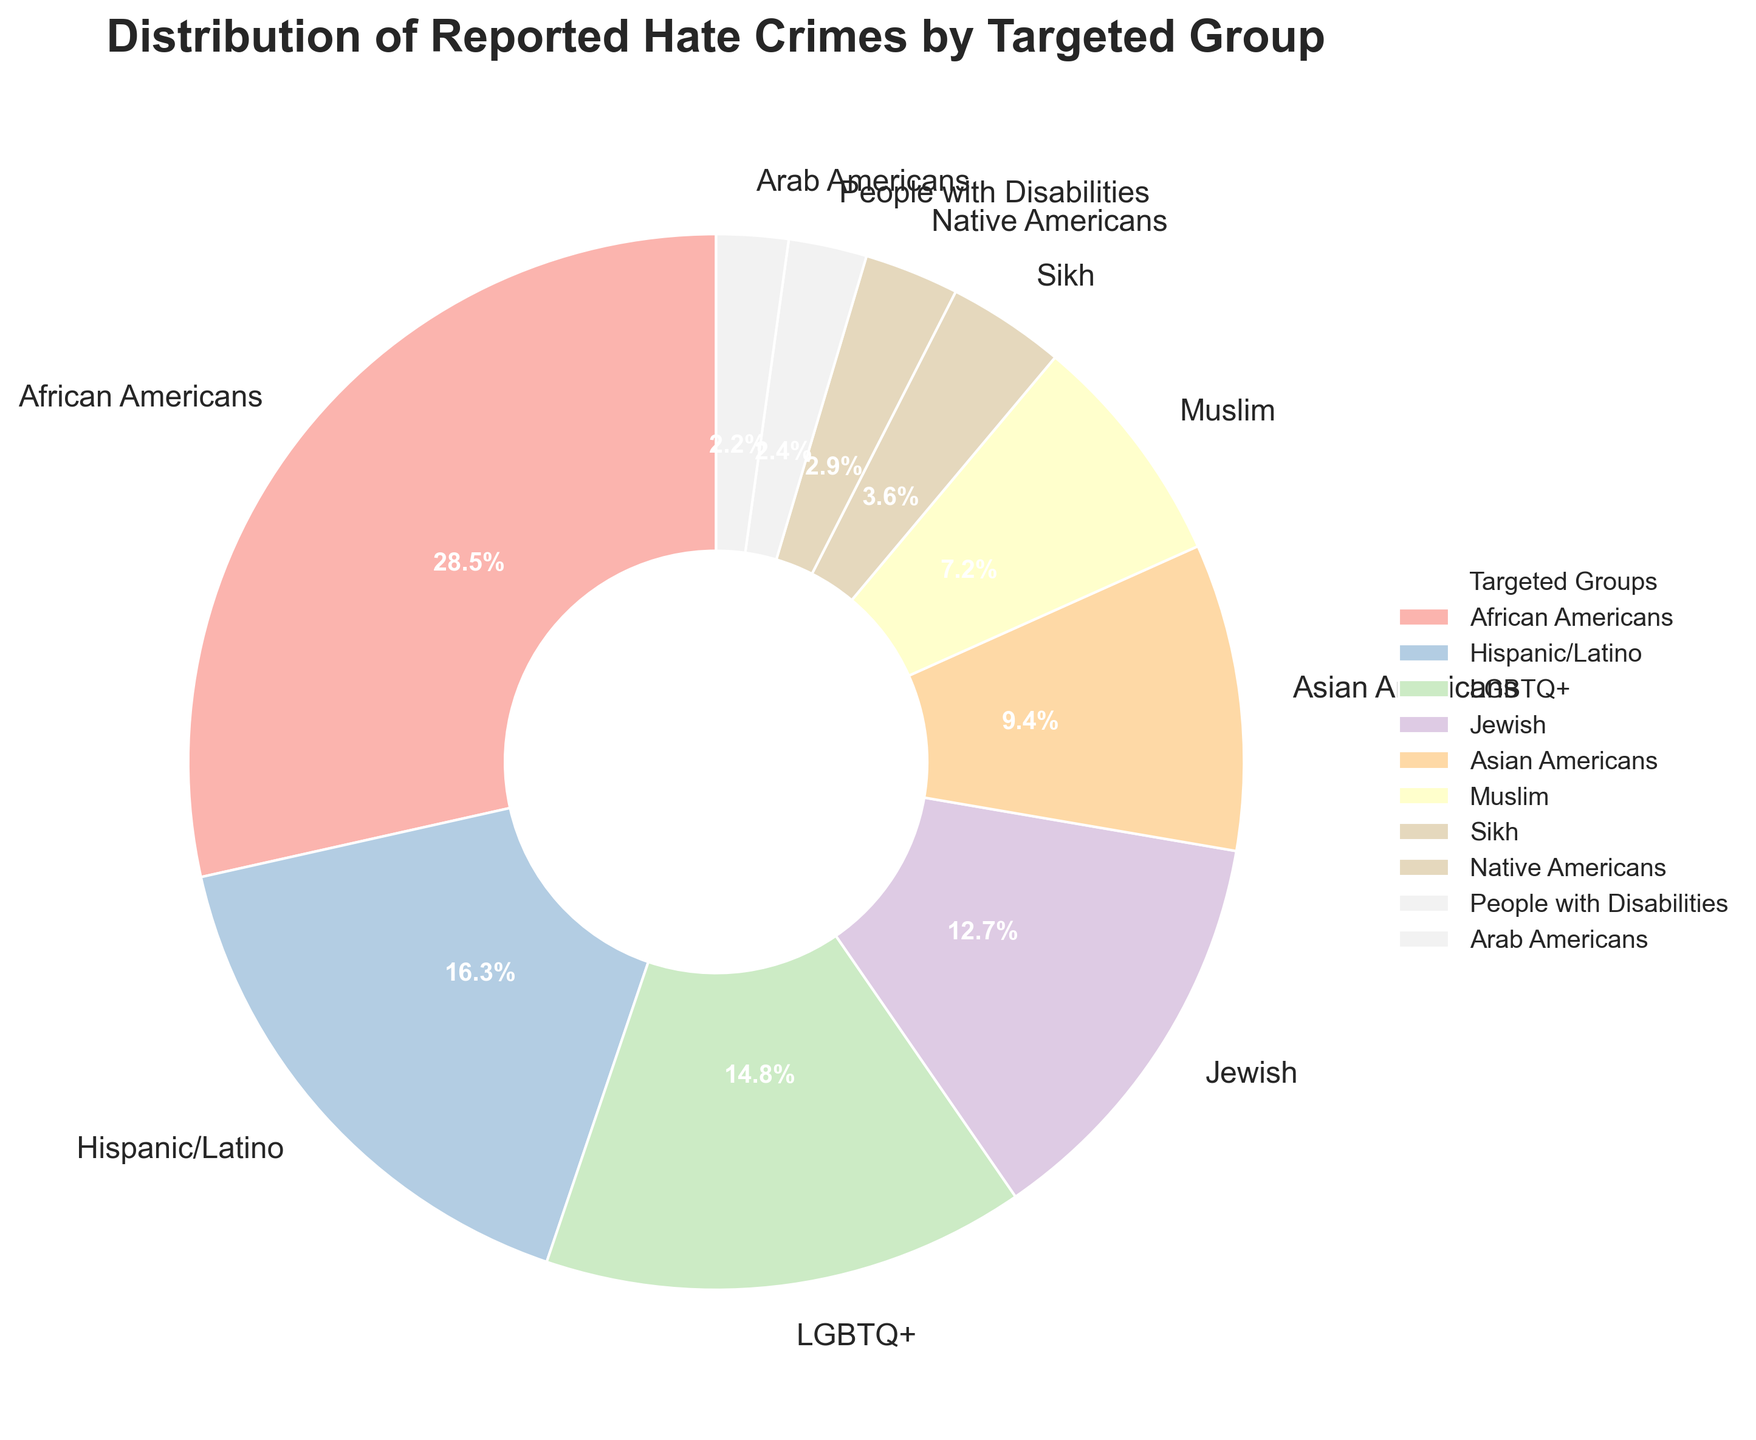Which group has the highest percentage of reported hate crimes? The figure shows a pie chart, and "African Americans" have the largest segment.
Answer: African Americans What percentage of reported hate crimes is targeted towards LGBTQ+ individuals? Refer to the pie chart segment labeled "LGBTQ+," which shows the percentage as 14.8%.
Answer: 14.8% How much higher is the percentage of hate crimes against African Americans compared to Asian Americans? The percentage for African Americans is 28.5% and for Asian Americans is 9.4%. Subtract 9.4 from 28.5 to find the difference.
Answer: 19.1% Are hate crimes against Hispanic/Latino individuals more frequent than those against Jewish individuals? Compare the segments labeled "Hispanic/Latino" (16.3%) and "Jewish" (12.7%). 16.3% is greater than 12.7%.
Answer: Yes What is the combined percentage of reported hate crimes targeting Jewish, Muslim, and Sikh individuals? Add the percentages of the three groups: 12.7% (Jewish) + 7.2% (Muslim) + 3.6% (Sikh).
Answer: 23.5% Which targeted group has the smallest percentage of reported hate crimes? Refer to the smallest segment in the pie chart, which is "Arab Americans" at 2.2%.
Answer: Arab Americans How does the percentage of reported hate crimes against People with Disabilities compare to those against Native Americans? Compare the segments for "People with Disabilities" (2.4%) and "Native Americans" (2.9%). 2.4% is less than 2.9%.
Answer: Less What is the difference in the percentage of hate crimes committed against Muslim and Native American individuals? Subtract the percentage of hate crimes against Native Americans (2.9%) from those against Muslims (7.2%).
Answer: 4.3% If the percentage of hate crimes against African Americans, Hispanic/Latino, and LGBTQ+ communities were combined, what would be the sum? Add the percentages: 28.5% (African Americans) + 16.3% (Hispanic/Latino) + 14.8% (LGBTQ+).
Answer: 59.6% Which color segment in the pie chart represents Sikh individuals? The pie chart uses colors from the Pastel1 colormap, and the segment for Sikh individuals is a distinct color that can be visually identified based on the provided order.
Answer: The color can be visually confirmed from the chart 